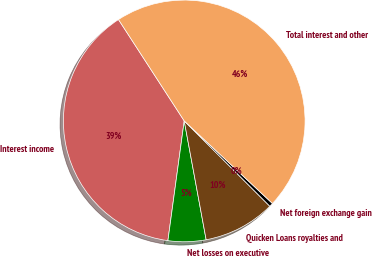<chart> <loc_0><loc_0><loc_500><loc_500><pie_chart><fcel>Interest income<fcel>Net losses on executive<fcel>Quicken Loans royalties and<fcel>Net foreign exchange gain<fcel>Total interest and other<nl><fcel>38.69%<fcel>5.06%<fcel>9.62%<fcel>0.5%<fcel>46.13%<nl></chart> 